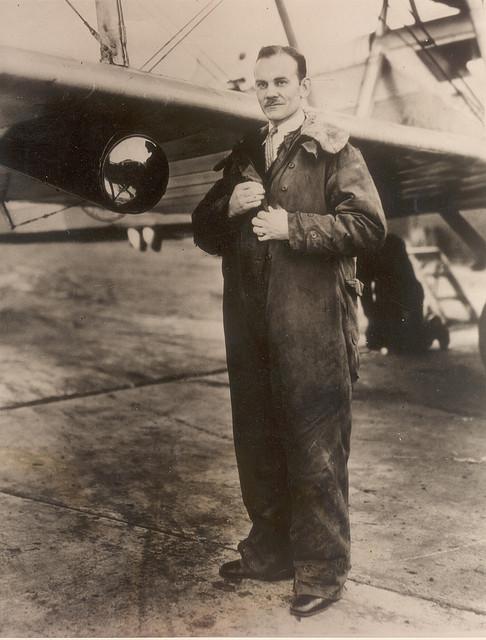Is this an old picture?
Keep it brief. Yes. What is the man standing near?
Give a very brief answer. Plane. What color are the man's shoes in this photograph?
Short answer required. Black. 